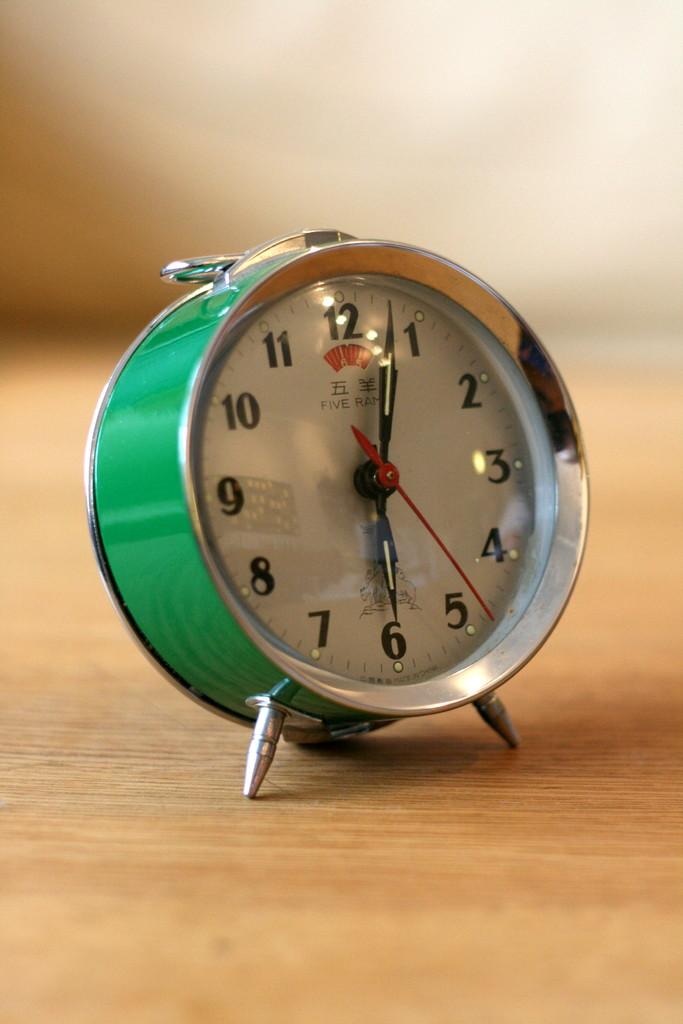What time is it?
Provide a short and direct response. 6:03. What number is at the top?
Give a very brief answer. 12. 